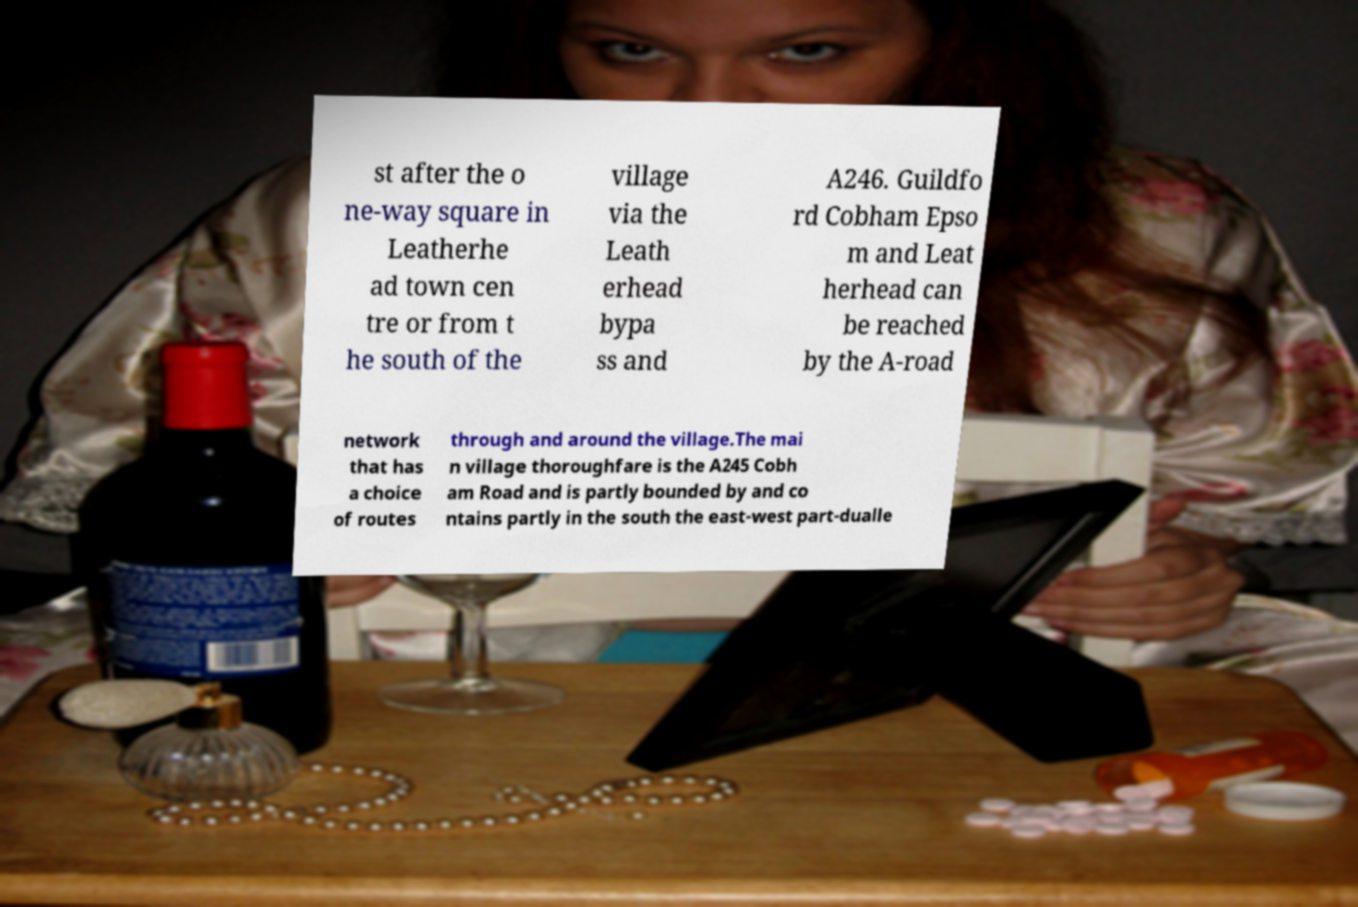Could you extract and type out the text from this image? st after the o ne-way square in Leatherhe ad town cen tre or from t he south of the village via the Leath erhead bypa ss and A246. Guildfo rd Cobham Epso m and Leat herhead can be reached by the A-road network that has a choice of routes through and around the village.The mai n village thoroughfare is the A245 Cobh am Road and is partly bounded by and co ntains partly in the south the east-west part-dualle 